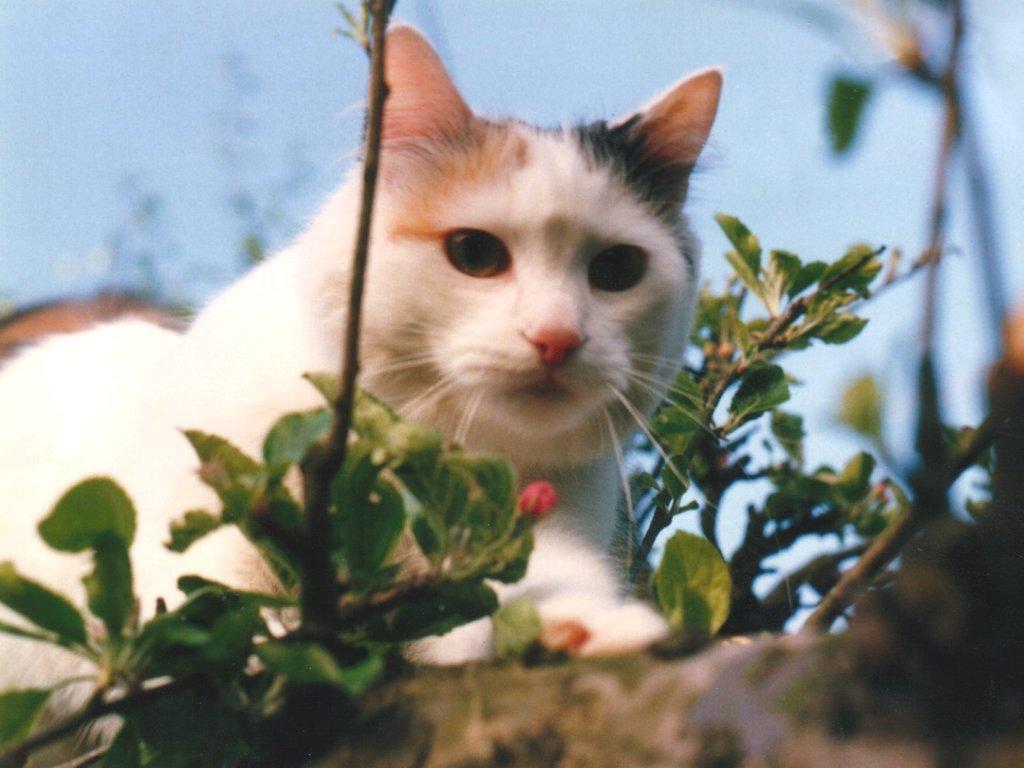Describe this image in one or two sentences. In this picture we can see a cat. There is a flower pot on the right side. We can see a few plants on the right side. Sky is blue in color. 